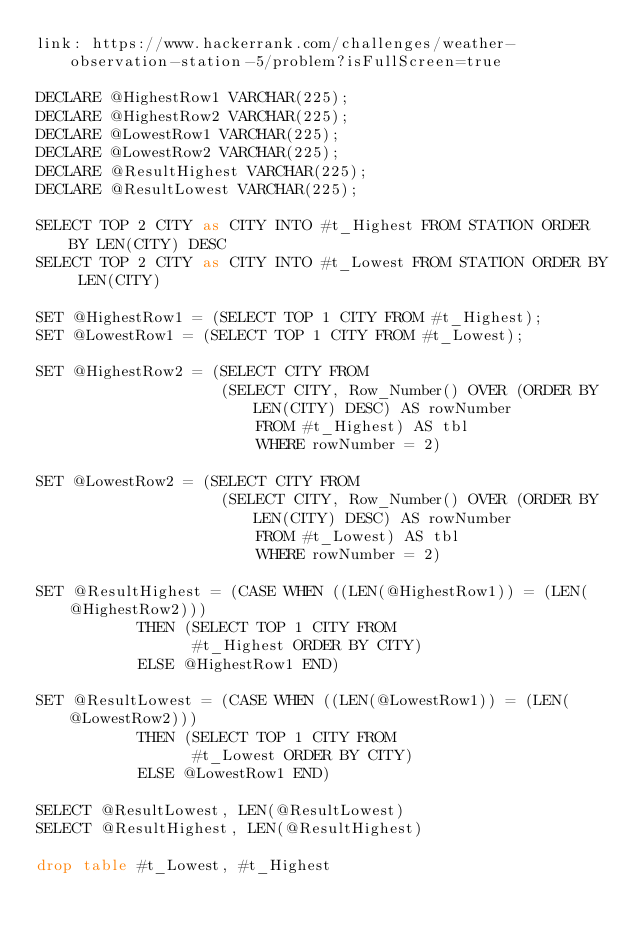Convert code to text. <code><loc_0><loc_0><loc_500><loc_500><_SQL_>link: https://www.hackerrank.com/challenges/weather-observation-station-5/problem?isFullScreen=true

DECLARE @HighestRow1 VARCHAR(225);
DECLARE @HighestRow2 VARCHAR(225);
DECLARE @LowestRow1 VARCHAR(225);
DECLARE @LowestRow2 VARCHAR(225);
DECLARE @ResultHighest VARCHAR(225);
DECLARE @ResultLowest VARCHAR(225);

SELECT TOP 2 CITY as CITY INTO #t_Highest FROM STATION ORDER BY LEN(CITY) DESC
SELECT TOP 2 CITY as CITY INTO #t_Lowest FROM STATION ORDER BY LEN(CITY)

SET @HighestRow1 = (SELECT TOP 1 CITY FROM #t_Highest);
SET @LowestRow1 = (SELECT TOP 1 CITY FROM #t_Lowest);

SET @HighestRow2 = (SELECT CITY FROM 
                    (SELECT CITY, Row_Number() OVER (ORDER BY LEN(CITY) DESC) AS rowNumber
                        FROM #t_Highest) AS tbl
                        WHERE rowNumber = 2)
                    
SET @LowestRow2 = (SELECT CITY FROM 
                    (SELECT CITY, Row_Number() OVER (ORDER BY LEN(CITY) DESC) AS rowNumber
                        FROM #t_Lowest) AS tbl
                        WHERE rowNumber = 2)
                        
SET @ResultHighest = (CASE WHEN ((LEN(@HighestRow1)) = (LEN(@HighestRow2))) 
           THEN (SELECT TOP 1 CITY FROM 
                 #t_Highest ORDER BY CITY)
           ELSE @HighestRow1 END)
           
SET @ResultLowest = (CASE WHEN ((LEN(@LowestRow1)) = (LEN(@LowestRow2))) 
           THEN (SELECT TOP 1 CITY FROM 
                 #t_Lowest ORDER BY CITY)
           ELSE @LowestRow1 END)
           
SELECT @ResultLowest, LEN(@ResultLowest)
SELECT @ResultHighest, LEN(@ResultHighest)

drop table #t_Lowest, #t_Highest
</code> 